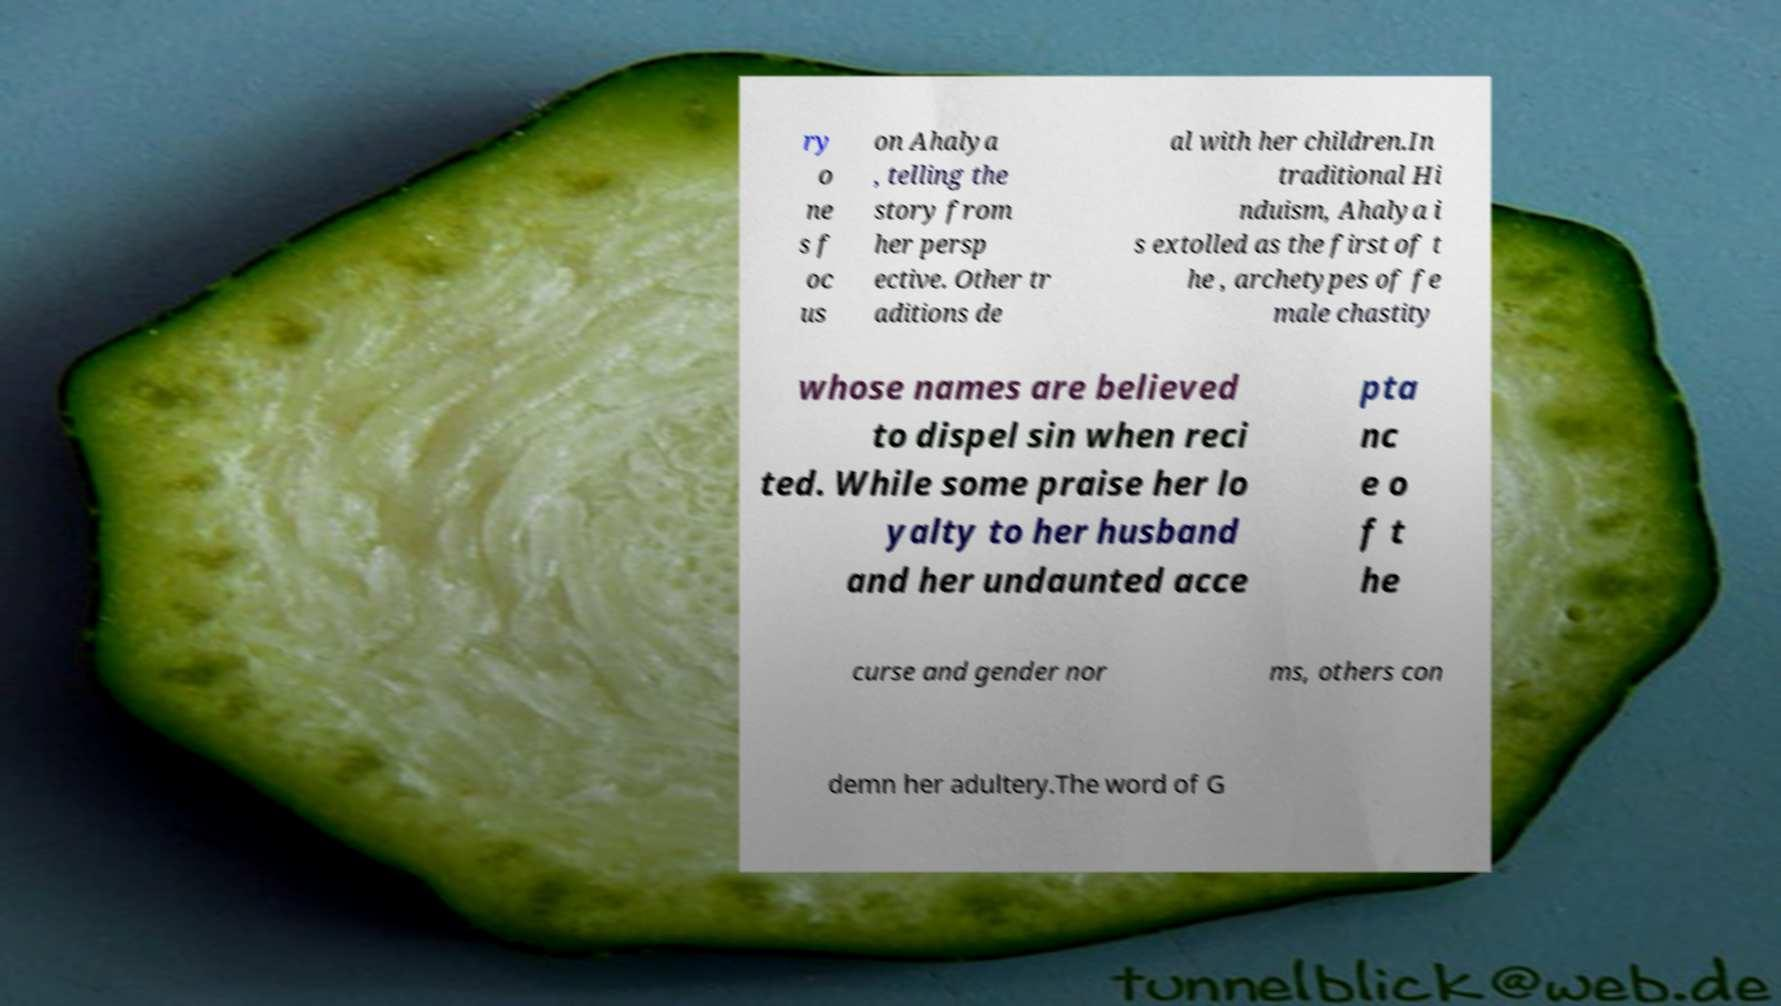There's text embedded in this image that I need extracted. Can you transcribe it verbatim? ry o ne s f oc us on Ahalya , telling the story from her persp ective. Other tr aditions de al with her children.In traditional Hi nduism, Ahalya i s extolled as the first of t he , archetypes of fe male chastity whose names are believed to dispel sin when reci ted. While some praise her lo yalty to her husband and her undaunted acce pta nc e o f t he curse and gender nor ms, others con demn her adultery.The word of G 